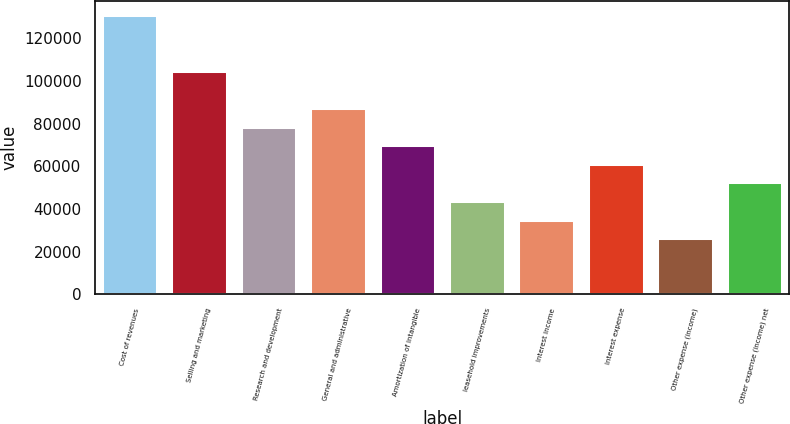Convert chart. <chart><loc_0><loc_0><loc_500><loc_500><bar_chart><fcel>Cost of revenues<fcel>Selling and marketing<fcel>Research and development<fcel>General and administrative<fcel>Amortization of intangible<fcel>leasehold improvements<fcel>Interest income<fcel>Interest expense<fcel>Other expense (income)<fcel>Other expense (income) net<nl><fcel>131124<fcel>104899<fcel>78674.4<fcel>87416<fcel>69932.9<fcel>43708.2<fcel>34966.7<fcel>61191.3<fcel>26225.2<fcel>52449.8<nl></chart> 